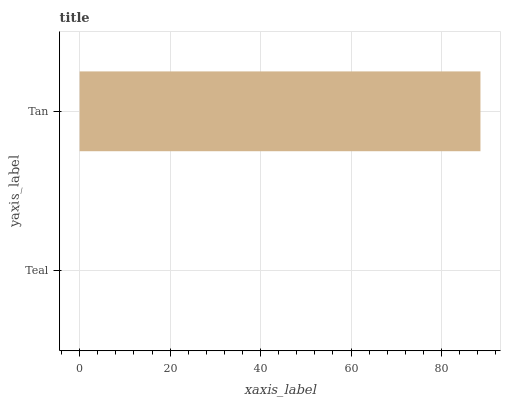Is Teal the minimum?
Answer yes or no. Yes. Is Tan the maximum?
Answer yes or no. Yes. Is Tan the minimum?
Answer yes or no. No. Is Tan greater than Teal?
Answer yes or no. Yes. Is Teal less than Tan?
Answer yes or no. Yes. Is Teal greater than Tan?
Answer yes or no. No. Is Tan less than Teal?
Answer yes or no. No. Is Tan the high median?
Answer yes or no. Yes. Is Teal the low median?
Answer yes or no. Yes. Is Teal the high median?
Answer yes or no. No. Is Tan the low median?
Answer yes or no. No. 